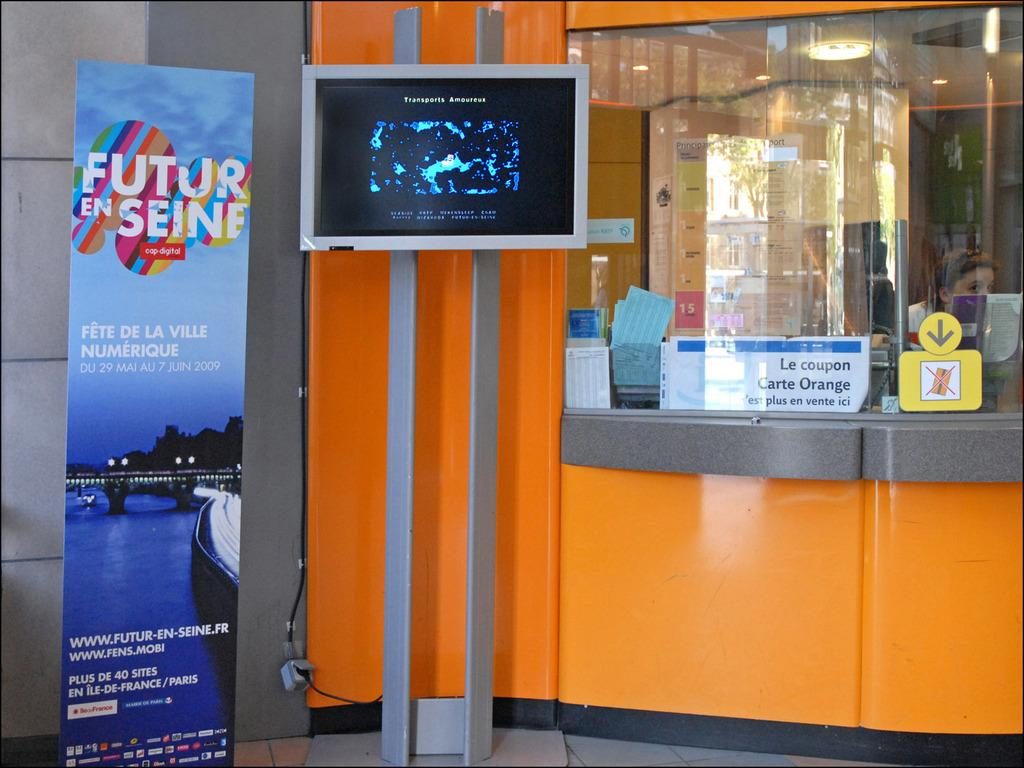<image>
Offer a succinct explanation of the picture presented. A sign for Futur En Seine is next to an orange counter. 